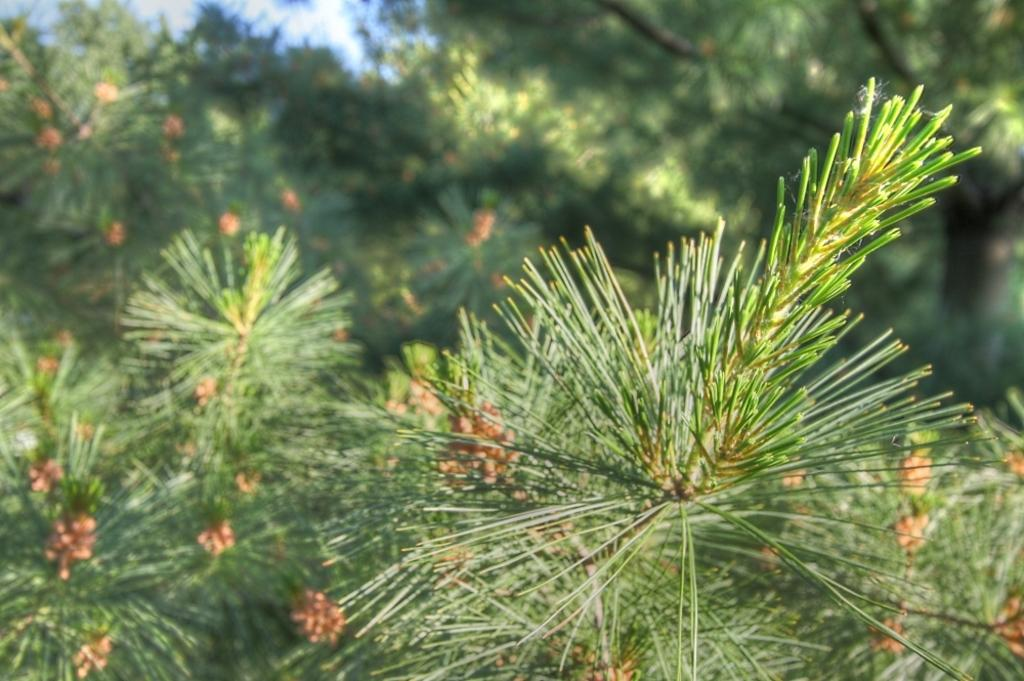What type of vegetation can be seen in the image? There are trees in the image. What color are the flowers on the trees? The trees have orange flowers. Can you describe the background of the image? The background of the image is blurred. What type of fan is visible in the image? There is no fan present in the image. How does the brake work on the orange flowers in the image? The image does not depict a brake or any mechanism related to braking. 